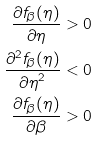Convert formula to latex. <formula><loc_0><loc_0><loc_500><loc_500>\frac { \partial f _ { \beta } ( \eta ) } { \partial \eta } & > 0 \\ \frac { \partial ^ { 2 } f _ { \beta } ( \eta ) } { { \partial \eta } ^ { 2 } } & < 0 \\ \frac { \partial f _ { \beta } ( \eta ) } { \partial \beta } & > 0</formula> 